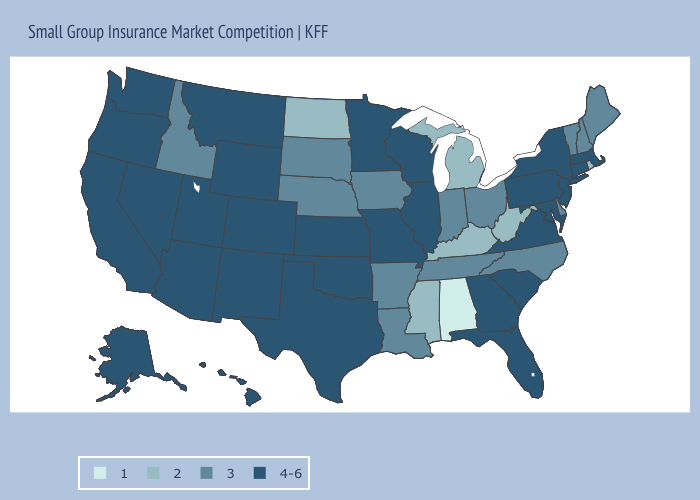Does Idaho have the highest value in the West?
Quick response, please. No. Name the states that have a value in the range 1?
Answer briefly. Alabama. What is the value of South Dakota?
Be succinct. 3. What is the lowest value in the MidWest?
Quick response, please. 2. Name the states that have a value in the range 4-6?
Quick response, please. Alaska, Arizona, California, Colorado, Connecticut, Florida, Georgia, Hawaii, Illinois, Kansas, Maryland, Massachusetts, Minnesota, Missouri, Montana, Nevada, New Jersey, New Mexico, New York, Oklahoma, Oregon, Pennsylvania, South Carolina, Texas, Utah, Virginia, Washington, Wisconsin, Wyoming. Does the map have missing data?
Keep it brief. No. Name the states that have a value in the range 1?
Write a very short answer. Alabama. What is the value of Iowa?
Give a very brief answer. 3. Among the states that border South Carolina , does North Carolina have the lowest value?
Write a very short answer. Yes. What is the value of Illinois?
Write a very short answer. 4-6. Does New York have a higher value than Missouri?
Give a very brief answer. No. Name the states that have a value in the range 1?
Quick response, please. Alabama. Does Alabama have the lowest value in the USA?
Write a very short answer. Yes. Does the first symbol in the legend represent the smallest category?
Be succinct. Yes. Which states hav the highest value in the Northeast?
Be succinct. Connecticut, Massachusetts, New Jersey, New York, Pennsylvania. 